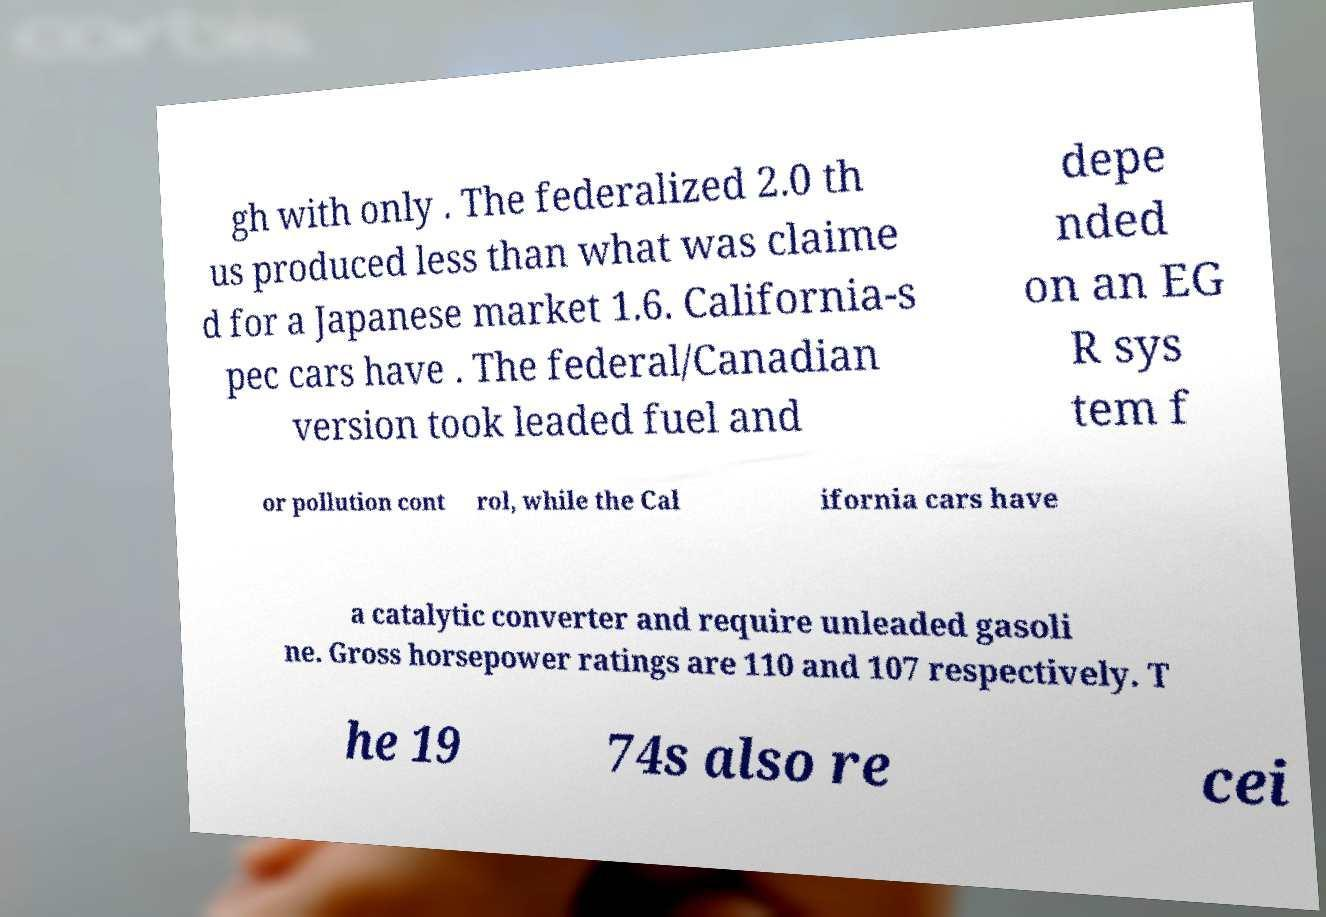There's text embedded in this image that I need extracted. Can you transcribe it verbatim? gh with only . The federalized 2.0 th us produced less than what was claime d for a Japanese market 1.6. California-s pec cars have . The federal/Canadian version took leaded fuel and depe nded on an EG R sys tem f or pollution cont rol, while the Cal ifornia cars have a catalytic converter and require unleaded gasoli ne. Gross horsepower ratings are 110 and 107 respectively. T he 19 74s also re cei 